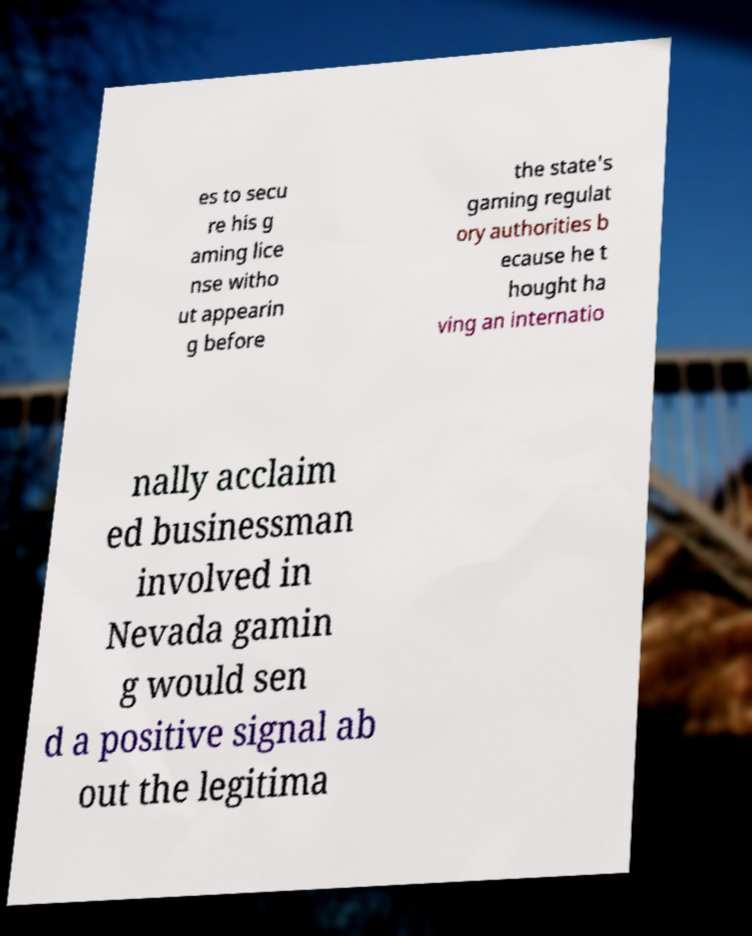What messages or text are displayed in this image? I need them in a readable, typed format. es to secu re his g aming lice nse witho ut appearin g before the state's gaming regulat ory authorities b ecause he t hought ha ving an internatio nally acclaim ed businessman involved in Nevada gamin g would sen d a positive signal ab out the legitima 